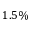Convert formula to latex. <formula><loc_0><loc_0><loc_500><loc_500>1 . 5 \%</formula> 